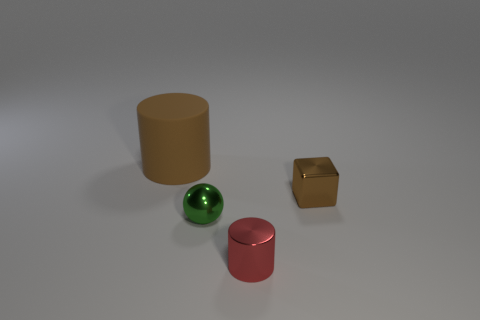Add 1 gray cubes. How many objects exist? 5 Subtract all balls. How many objects are left? 3 Add 2 small red shiny cylinders. How many small red shiny cylinders exist? 3 Subtract 0 red blocks. How many objects are left? 4 Subtract all yellow cylinders. Subtract all green balls. How many objects are left? 3 Add 4 rubber cylinders. How many rubber cylinders are left? 5 